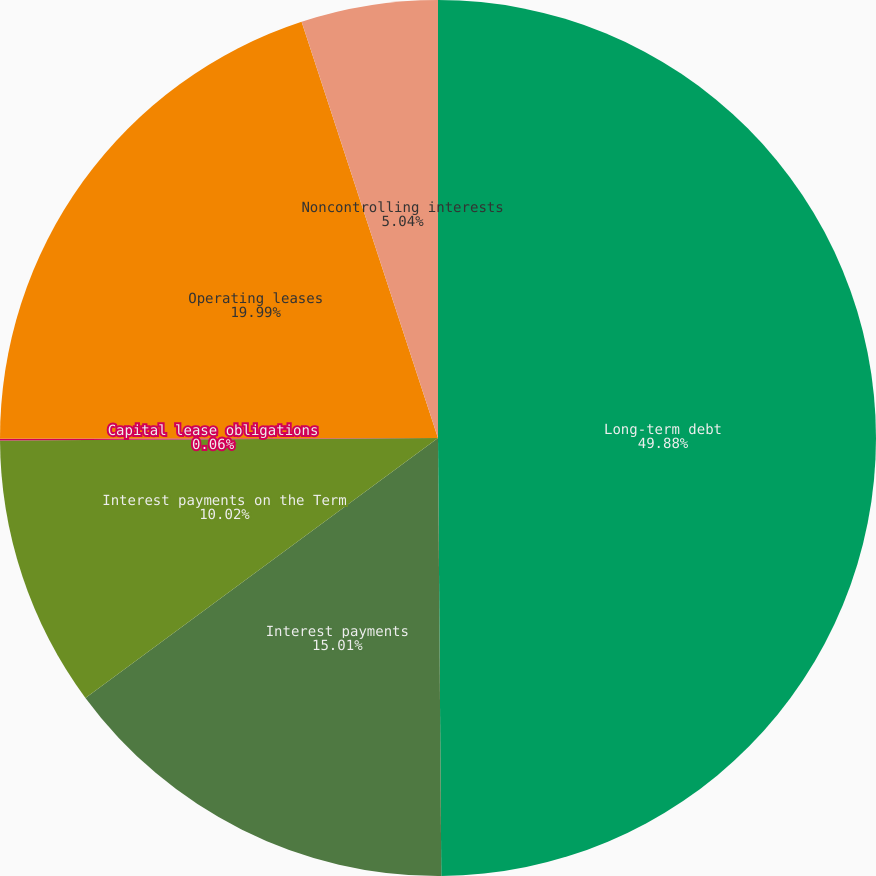Convert chart to OTSL. <chart><loc_0><loc_0><loc_500><loc_500><pie_chart><fcel>Long-term debt<fcel>Interest payments<fcel>Interest payments on the Term<fcel>Capital lease obligations<fcel>Operating leases<fcel>Noncontrolling interests<nl><fcel>49.88%<fcel>15.01%<fcel>10.02%<fcel>0.06%<fcel>19.99%<fcel>5.04%<nl></chart> 